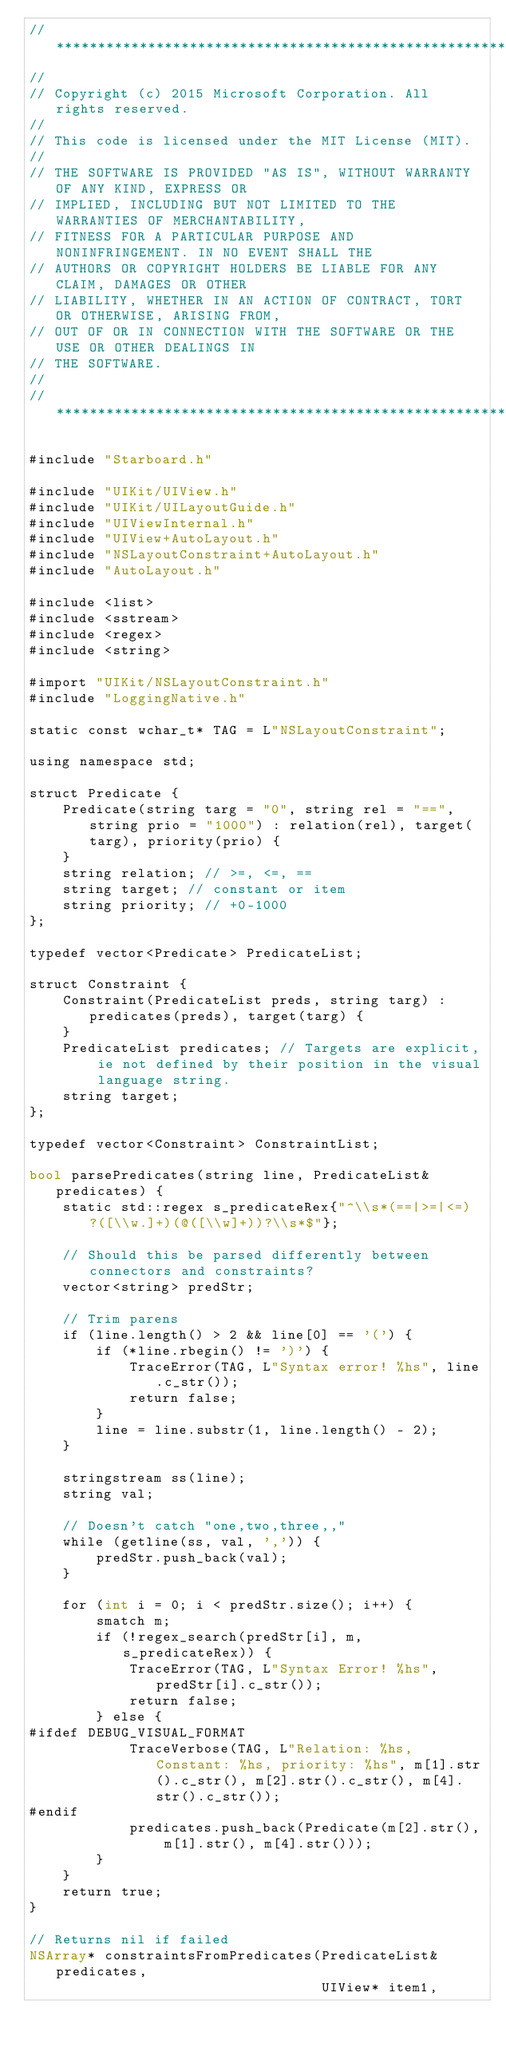<code> <loc_0><loc_0><loc_500><loc_500><_ObjectiveC_>//******************************************************************************
//
// Copyright (c) 2015 Microsoft Corporation. All rights reserved.
//
// This code is licensed under the MIT License (MIT).
//
// THE SOFTWARE IS PROVIDED "AS IS", WITHOUT WARRANTY OF ANY KIND, EXPRESS OR
// IMPLIED, INCLUDING BUT NOT LIMITED TO THE WARRANTIES OF MERCHANTABILITY,
// FITNESS FOR A PARTICULAR PURPOSE AND NONINFRINGEMENT. IN NO EVENT SHALL THE
// AUTHORS OR COPYRIGHT HOLDERS BE LIABLE FOR ANY CLAIM, DAMAGES OR OTHER
// LIABILITY, WHETHER IN AN ACTION OF CONTRACT, TORT OR OTHERWISE, ARISING FROM,
// OUT OF OR IN CONNECTION WITH THE SOFTWARE OR THE USE OR OTHER DEALINGS IN
// THE SOFTWARE.
//
//******************************************************************************

#include "Starboard.h"

#include "UIKit/UIView.h"
#include "UIKit/UILayoutGuide.h"
#include "UIViewInternal.h"
#include "UIView+AutoLayout.h"
#include "NSLayoutConstraint+AutoLayout.h"
#include "AutoLayout.h"

#include <list>
#include <sstream>
#include <regex>
#include <string>

#import "UIKit/NSLayoutConstraint.h"
#include "LoggingNative.h"

static const wchar_t* TAG = L"NSLayoutConstraint";

using namespace std;

struct Predicate {
    Predicate(string targ = "0", string rel = "==", string prio = "1000") : relation(rel), target(targ), priority(prio) {
    }
    string relation; // >=, <=, ==
    string target; // constant or item
    string priority; // +0-1000
};

typedef vector<Predicate> PredicateList;

struct Constraint {
    Constraint(PredicateList preds, string targ) : predicates(preds), target(targ) {
    }
    PredicateList predicates; // Targets are explicit, ie not defined by their position in the visual language string.
    string target;
};

typedef vector<Constraint> ConstraintList;

bool parsePredicates(string line, PredicateList& predicates) {
    static std::regex s_predicateRex{"^\\s*(==|>=|<=)?([\\w.]+)(@([\\w]+))?\\s*$"};

    // Should this be parsed differently between connectors and constraints?
    vector<string> predStr;

    // Trim parens
    if (line.length() > 2 && line[0] == '(') {
        if (*line.rbegin() != ')') {
            TraceError(TAG, L"Syntax error! %hs", line.c_str());
            return false;
        }
        line = line.substr(1, line.length() - 2);
    }

    stringstream ss(line);
    string val;

    // Doesn't catch "one,two,three,,"
    while (getline(ss, val, ',')) {
        predStr.push_back(val);
    }

    for (int i = 0; i < predStr.size(); i++) {
        smatch m;
        if (!regex_search(predStr[i], m, s_predicateRex)) {
            TraceError(TAG, L"Syntax Error! %hs", predStr[i].c_str());
            return false;
        } else {
#ifdef DEBUG_VISUAL_FORMAT
            TraceVerbose(TAG, L"Relation: %hs, Constant: %hs, priority: %hs", m[1].str().c_str(), m[2].str().c_str(), m[4].str().c_str());
#endif
            predicates.push_back(Predicate(m[2].str(), m[1].str(), m[4].str()));
        }
    }
    return true;
}

// Returns nil if failed
NSArray* constraintsFromPredicates(PredicateList& predicates,
                                   UIView* item1,</code> 